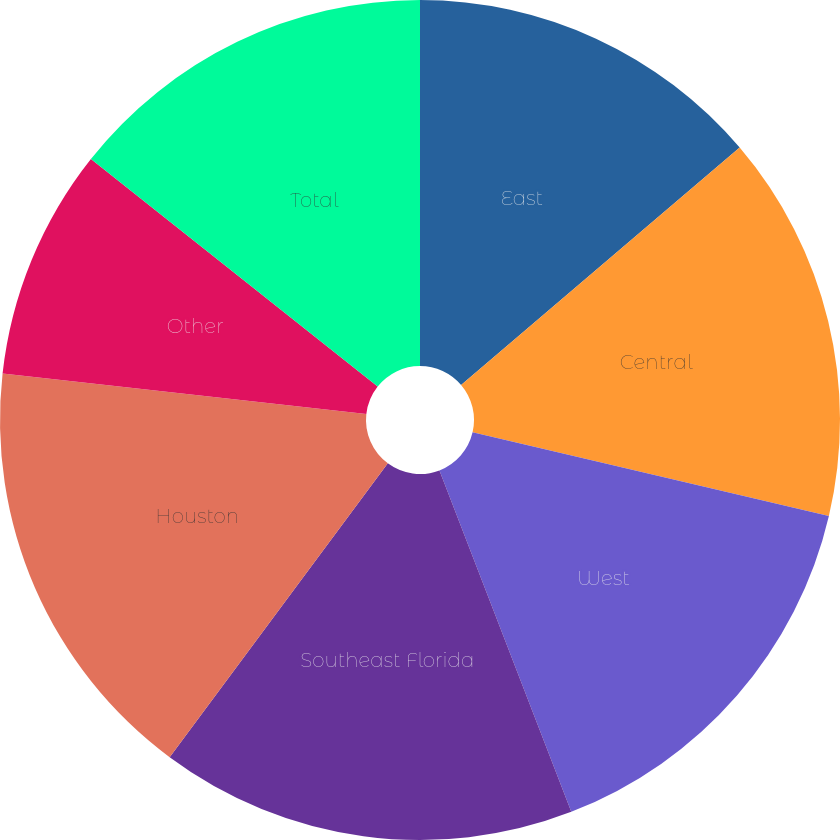<chart> <loc_0><loc_0><loc_500><loc_500><pie_chart><fcel>East<fcel>Central<fcel>West<fcel>Southeast Florida<fcel>Houston<fcel>Other<fcel>Total<nl><fcel>13.77%<fcel>14.9%<fcel>15.47%<fcel>16.03%<fcel>16.6%<fcel>8.91%<fcel>14.33%<nl></chart> 